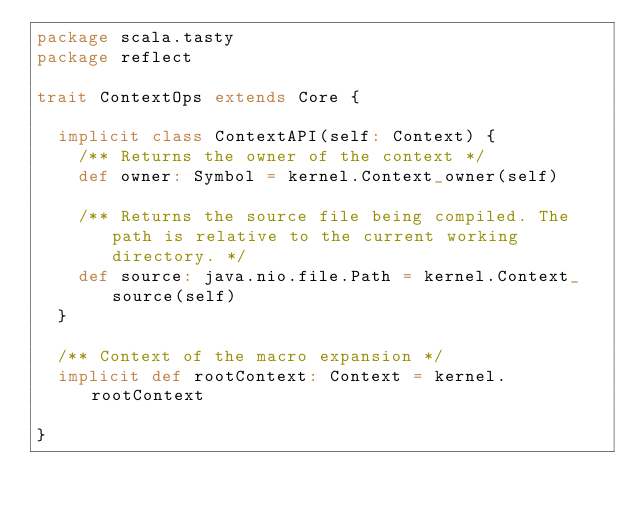Convert code to text. <code><loc_0><loc_0><loc_500><loc_500><_Scala_>package scala.tasty
package reflect

trait ContextOps extends Core {

  implicit class ContextAPI(self: Context) {
    /** Returns the owner of the context */
    def owner: Symbol = kernel.Context_owner(self)

    /** Returns the source file being compiled. The path is relative to the current working directory. */
    def source: java.nio.file.Path = kernel.Context_source(self)
  }

  /** Context of the macro expansion */
  implicit def rootContext: Context = kernel.rootContext

}
</code> 